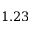<formula> <loc_0><loc_0><loc_500><loc_500>1 . 2 3</formula> 